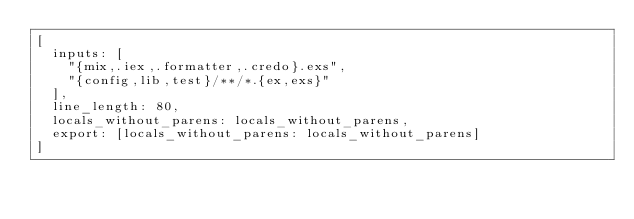<code> <loc_0><loc_0><loc_500><loc_500><_Elixir_>[
  inputs: [
    "{mix,.iex,.formatter,.credo}.exs",
    "{config,lib,test}/**/*.{ex,exs}"
  ],
  line_length: 80,
  locals_without_parens: locals_without_parens,
  export: [locals_without_parens: locals_without_parens]
]
</code> 